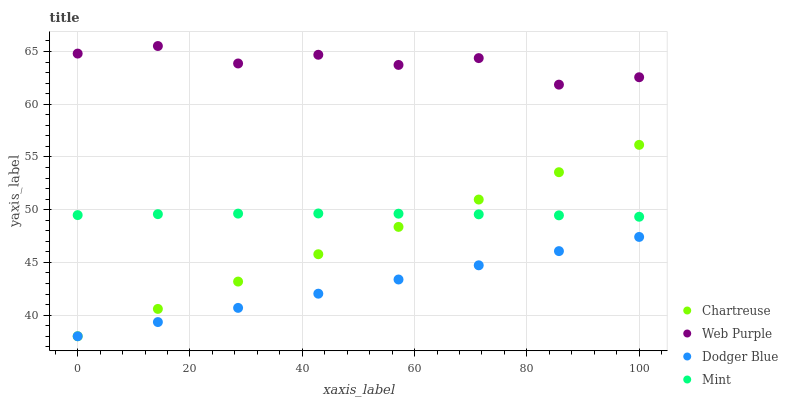Does Dodger Blue have the minimum area under the curve?
Answer yes or no. Yes. Does Web Purple have the maximum area under the curve?
Answer yes or no. Yes. Does Chartreuse have the minimum area under the curve?
Answer yes or no. No. Does Chartreuse have the maximum area under the curve?
Answer yes or no. No. Is Chartreuse the smoothest?
Answer yes or no. Yes. Is Web Purple the roughest?
Answer yes or no. Yes. Is Dodger Blue the smoothest?
Answer yes or no. No. Is Dodger Blue the roughest?
Answer yes or no. No. Does Chartreuse have the lowest value?
Answer yes or no. Yes. Does Web Purple have the lowest value?
Answer yes or no. No. Does Web Purple have the highest value?
Answer yes or no. Yes. Does Chartreuse have the highest value?
Answer yes or no. No. Is Dodger Blue less than Web Purple?
Answer yes or no. Yes. Is Web Purple greater than Dodger Blue?
Answer yes or no. Yes. Does Chartreuse intersect Dodger Blue?
Answer yes or no. Yes. Is Chartreuse less than Dodger Blue?
Answer yes or no. No. Is Chartreuse greater than Dodger Blue?
Answer yes or no. No. Does Dodger Blue intersect Web Purple?
Answer yes or no. No. 